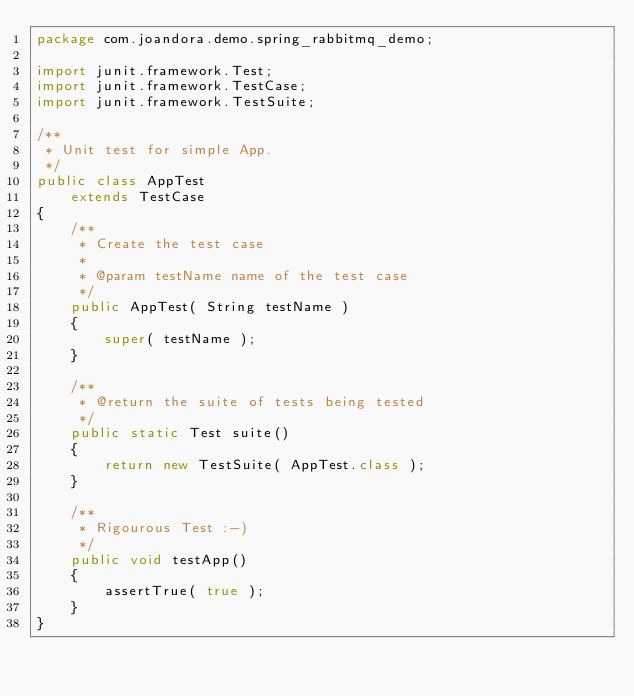<code> <loc_0><loc_0><loc_500><loc_500><_Java_>package com.joandora.demo.spring_rabbitmq_demo;

import junit.framework.Test;
import junit.framework.TestCase;
import junit.framework.TestSuite;

/**
 * Unit test for simple App.
 */
public class AppTest 
    extends TestCase
{
    /**
     * Create the test case
     *
     * @param testName name of the test case
     */
    public AppTest( String testName )
    {
        super( testName );
    }

    /**
     * @return the suite of tests being tested
     */
    public static Test suite()
    {
        return new TestSuite( AppTest.class );
    }

    /**
     * Rigourous Test :-)
     */
    public void testApp()
    {
        assertTrue( true );
    }
}
</code> 